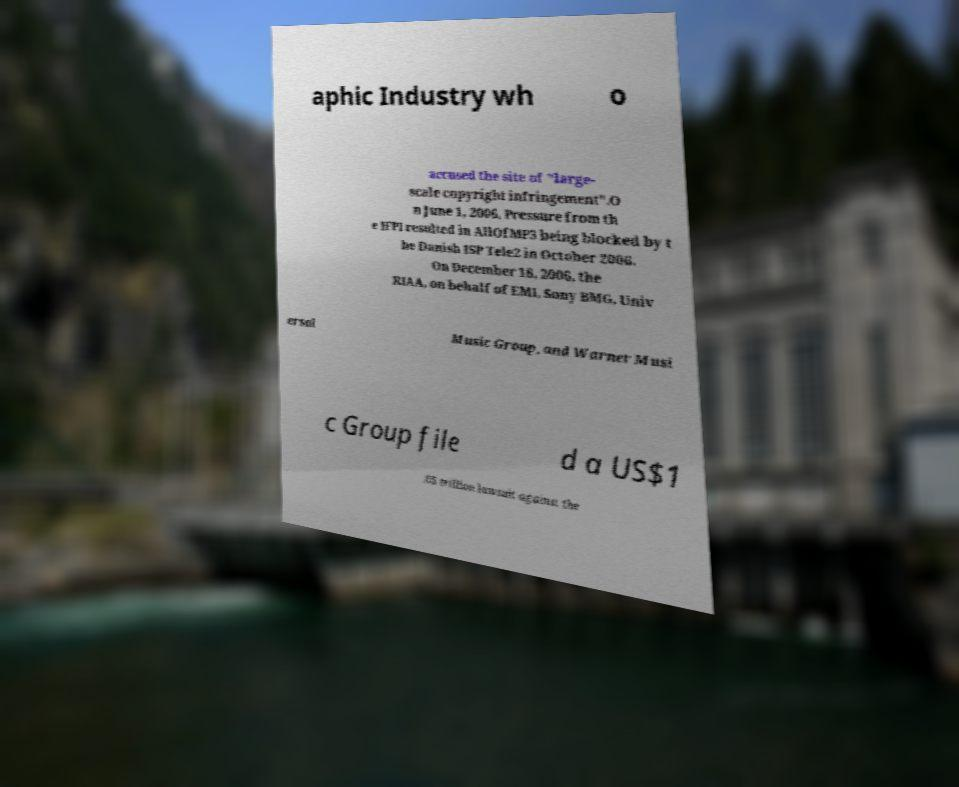Could you assist in decoding the text presented in this image and type it out clearly? aphic Industry wh o accused the site of "large- scale copyright infringement".O n June 1, 2006, Pressure from th e IFPI resulted in AllOfMP3 being blocked by t he Danish ISP Tele2 in October 2006. On December 18, 2006, the RIAA, on behalf of EMI, Sony BMG, Univ ersal Music Group, and Warner Musi c Group file d a US$1 .65 trillion lawsuit against the 